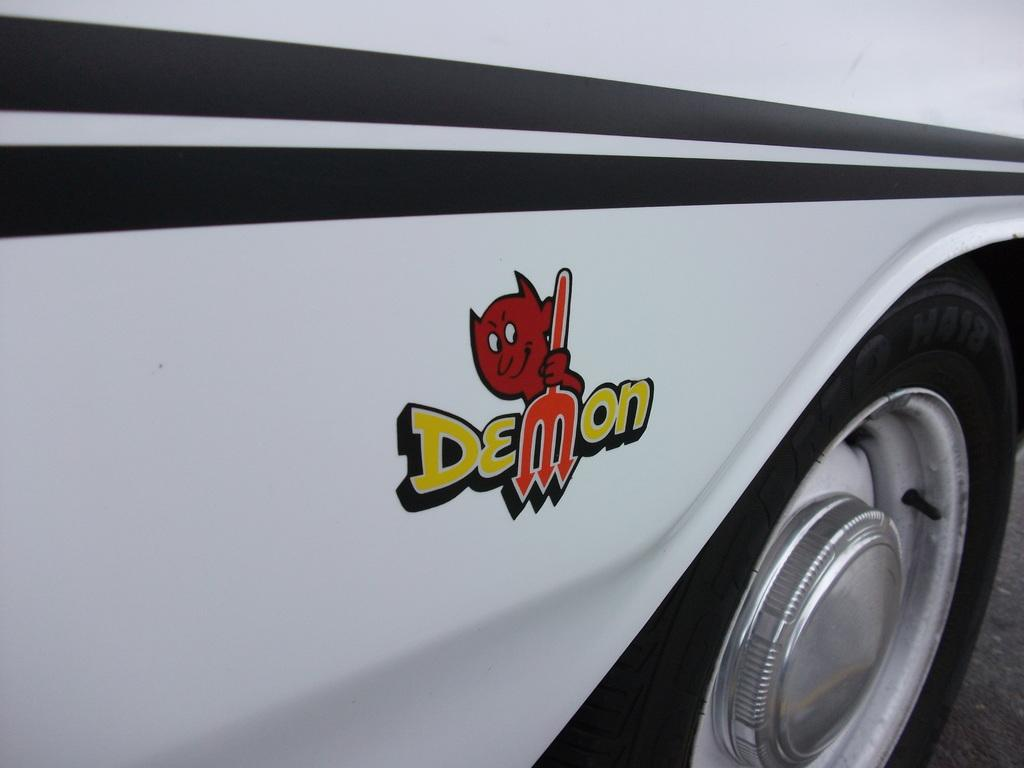What is the main subject of the image? The main subject of the image is a vehicle. Can you describe the colors of the vehicle? The vehicle has multiple colors, including white, black, red, orange, and yellow. Where is the vehicle located in the image? The vehicle is on the ground in the image. Who is the writer of the book that the vehicle is pushing in the image? There is no book or writer present in the image; it features a vehicle with multiple colors on the ground. 